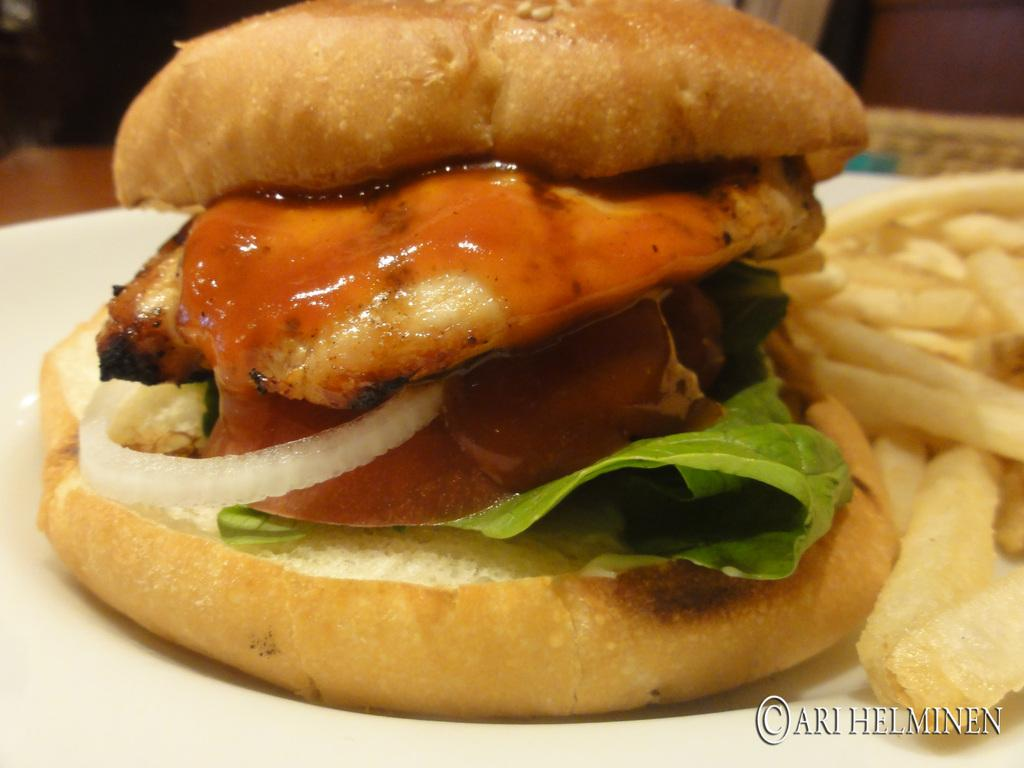What is on the plate that is visible at the bottom of the image? The plate contains a burger and french fries. What type of food is the main subject of the image? The main subject of the image is a burger. What other food item is present on the plate? French fries are also present on the plate. What can be seen in the background of the image? There are objects visible in the background of the image. What type of rhythm is being taught in the image? There is no indication of any teaching or rhythm in the image; it features a plate with a burger and french fries. 